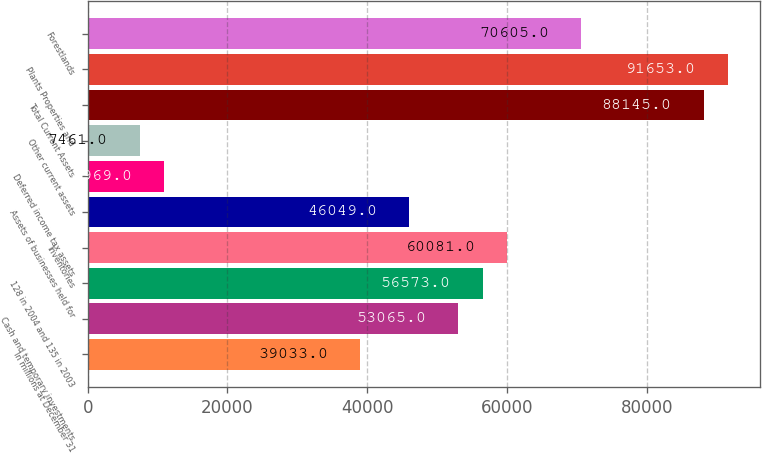Convert chart to OTSL. <chart><loc_0><loc_0><loc_500><loc_500><bar_chart><fcel>In millions at December 31<fcel>Cash and temporary investments<fcel>128 in 2004 and 135 in 2003<fcel>Inventories<fcel>Assets of businesses held for<fcel>Deferred income tax assets<fcel>Other current assets<fcel>Total Current Assets<fcel>Plants Properties and<fcel>Forestlands<nl><fcel>39033<fcel>53065<fcel>56573<fcel>60081<fcel>46049<fcel>10969<fcel>7461<fcel>88145<fcel>91653<fcel>70605<nl></chart> 